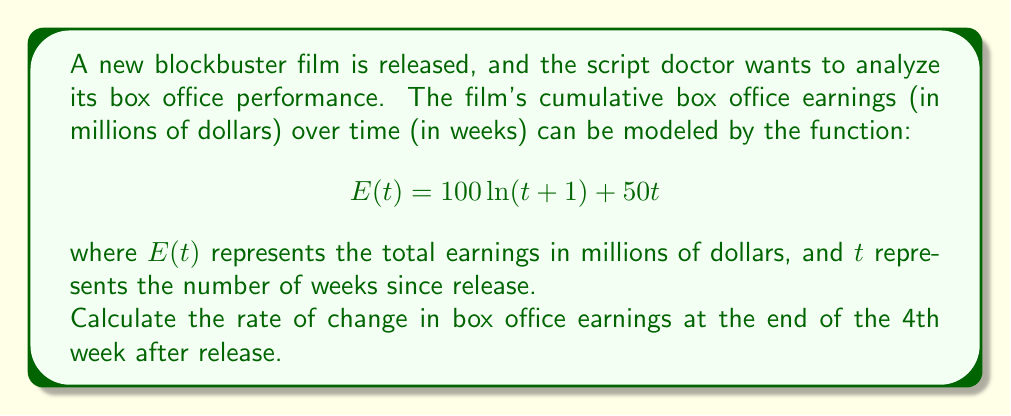Can you answer this question? To find the rate of change in box office earnings at a specific point in time, we need to calculate the derivative of the earnings function $E(t)$ and evaluate it at $t=4$.

1. First, let's find the derivative of $E(t)$:
   $$E(t) = 100\ln(t+1) + 50t$$
   $$E'(t) = 100 \cdot \frac{1}{t+1} + 50$$

2. Now, we need to evaluate $E'(t)$ at $t=4$:
   $$E'(4) = 100 \cdot \frac{1}{4+1} + 50$$
   $$E'(4) = 100 \cdot \frac{1}{5} + 50$$
   $$E'(4) = 20 + 50$$
   $$E'(4) = 70$$

3. Interpret the result:
   The rate of change in box office earnings at the end of the 4th week is 70 million dollars per week.
Answer: $70$ million dollars per week 